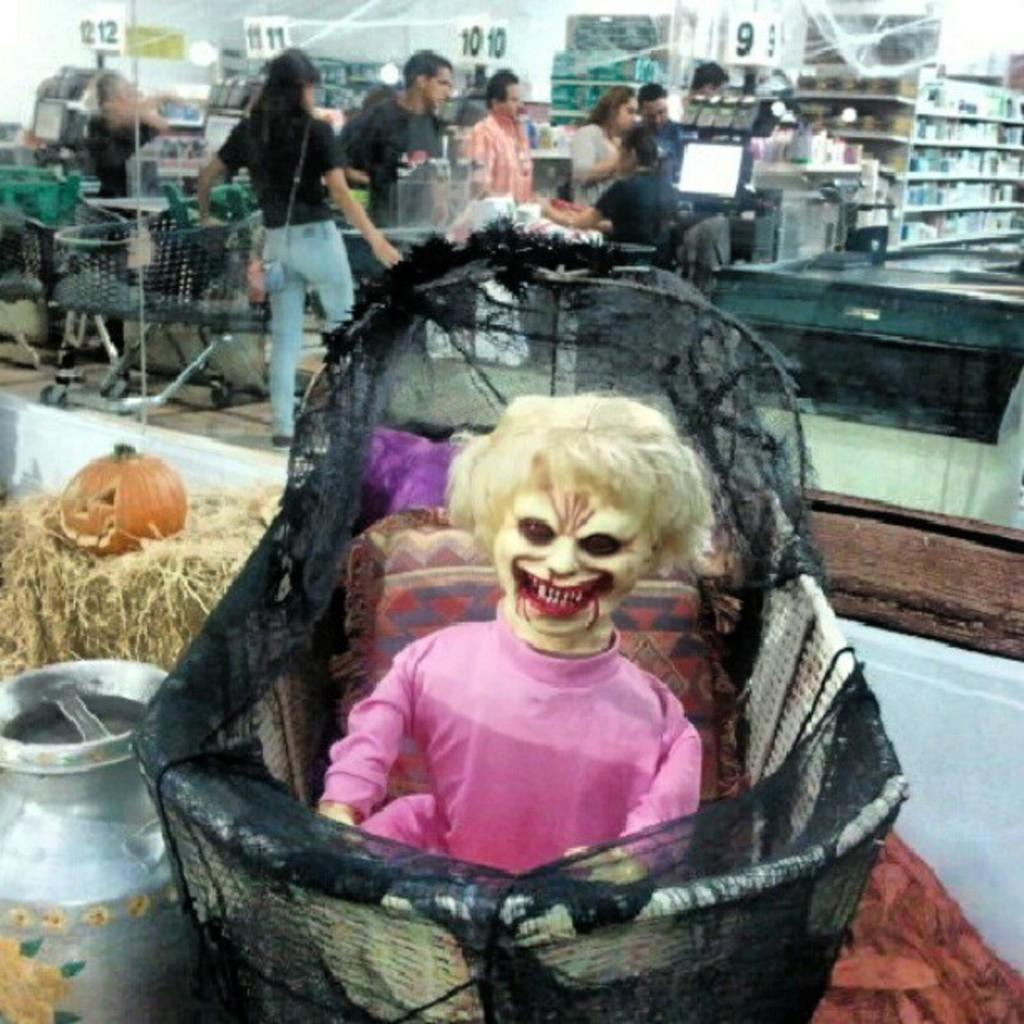What is the main subject of the image? There is a doll in the image. Where is the doll located? The doll is in a basket. What other object can be seen in the image? There is a pumpkin in the image. What is the surface beneath the pumpkin? The pumpkin is on dry grass. Can you describe the background of the image? There are people standing in the background of the image. What type of coach is driving the doll in the image? There is no coach or vehicle present in the image; the doll is in a basket. What plot is being developed in the image? The image does not depict a plot or storyline; it is a still image of a doll in a basket, a pumpkin on dry grass, and people in the background. 